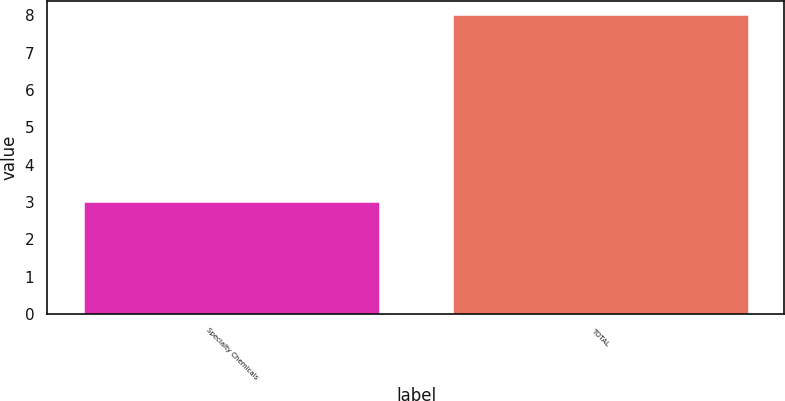Convert chart to OTSL. <chart><loc_0><loc_0><loc_500><loc_500><bar_chart><fcel>Specialty Chemicals<fcel>TOTAL<nl><fcel>3<fcel>8<nl></chart> 